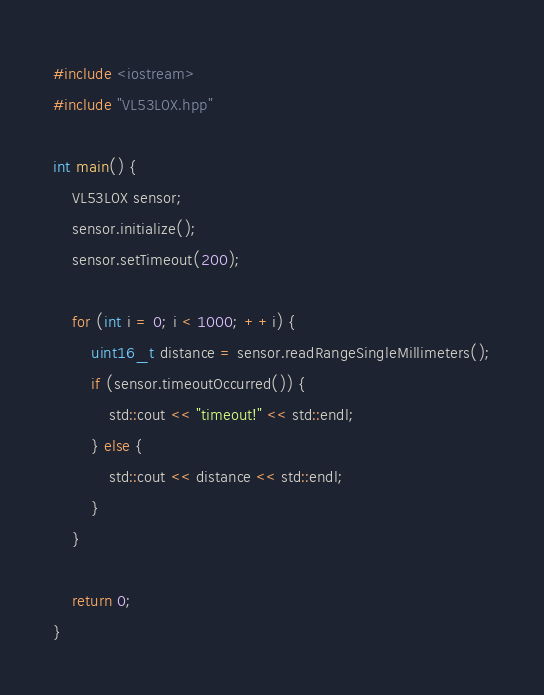Convert code to text. <code><loc_0><loc_0><loc_500><loc_500><_C++_>#include <iostream>
#include "VL53L0X.hpp"

int main() {
	VL53L0X sensor;
	sensor.initialize();
	sensor.setTimeout(200);

	for (int i = 0; i < 1000; ++i) {
		uint16_t distance = sensor.readRangeSingleMillimeters();
		if (sensor.timeoutOccurred()) {
			std::cout << "timeout!" << std::endl;
		} else {
			std::cout << distance << std::endl;
		}
	}

	return 0;
}
</code> 